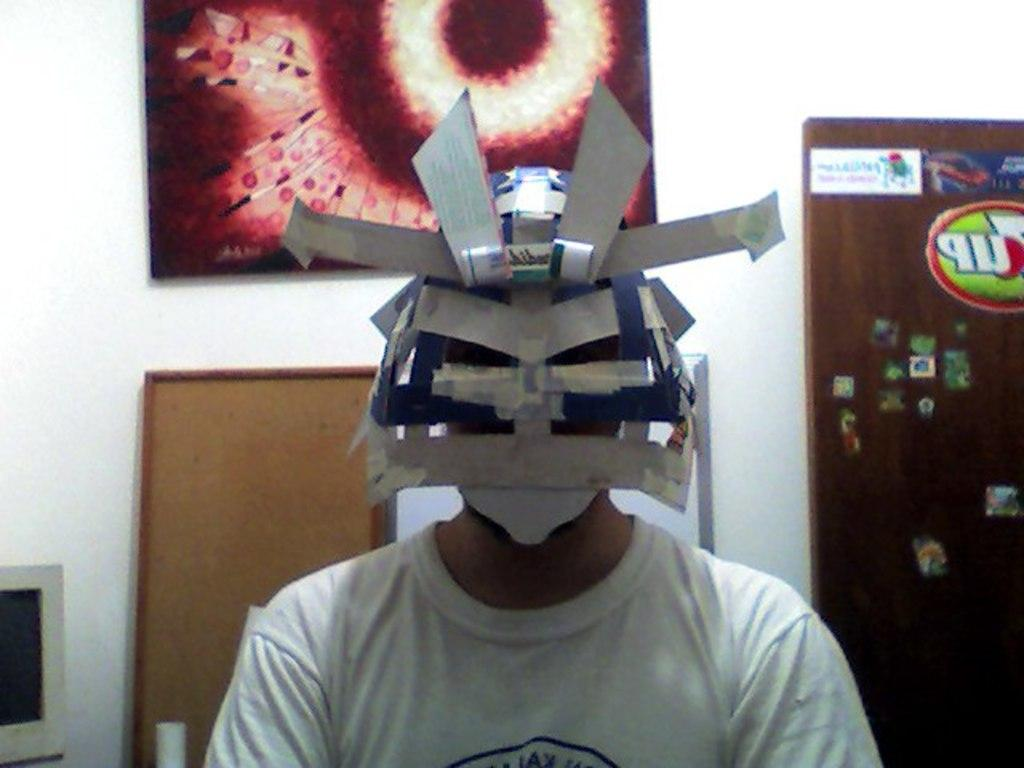What is the person in the image wearing on their face? The person in the image is wearing a mask. What can be seen behind the person in the image? There are boards and a wall behind the person in the image. What electronic device is visible on the left side of the image? There is a monitor on the left side of the image. What decorative elements are present on the board in the image? There are stickers on the board in the image. What type of suit is the person wearing in the image? The person in the image is not wearing a suit; they are wearing a mask. What kind of humor can be seen in the image? There is no humor present in the image; it is a straightforward depiction of a person with a mask and other elements. 